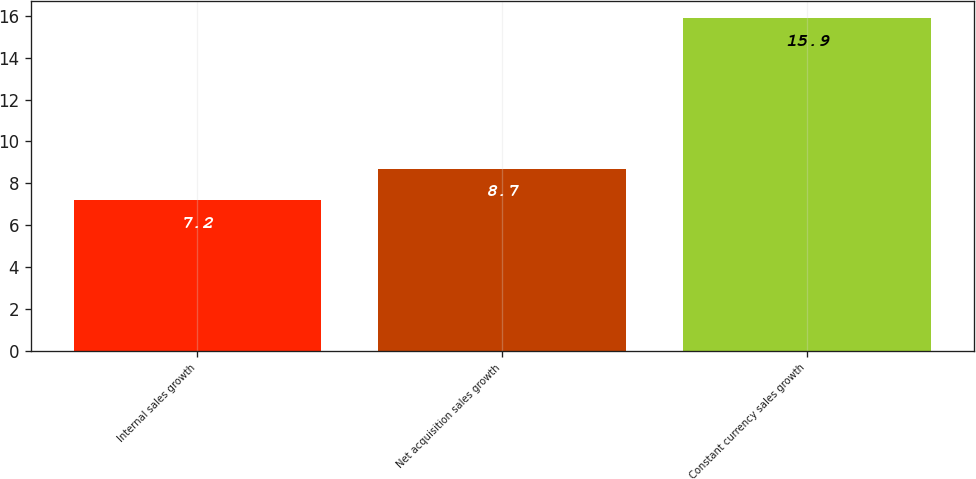Convert chart to OTSL. <chart><loc_0><loc_0><loc_500><loc_500><bar_chart><fcel>Internal sales growth<fcel>Net acquisition sales growth<fcel>Constant currency sales growth<nl><fcel>7.2<fcel>8.7<fcel>15.9<nl></chart> 